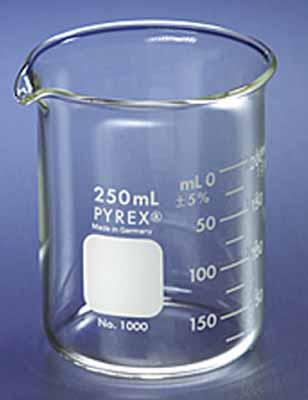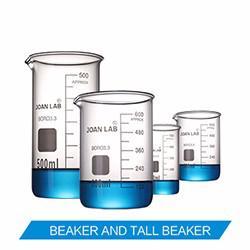The first image is the image on the left, the second image is the image on the right. Analyze the images presented: Is the assertion "There is exactly one empty beaker." valid? Answer yes or no. Yes. The first image is the image on the left, the second image is the image on the right. Assess this claim about the two images: "The right image shows multiple beakers.". Correct or not? Answer yes or no. Yes. 